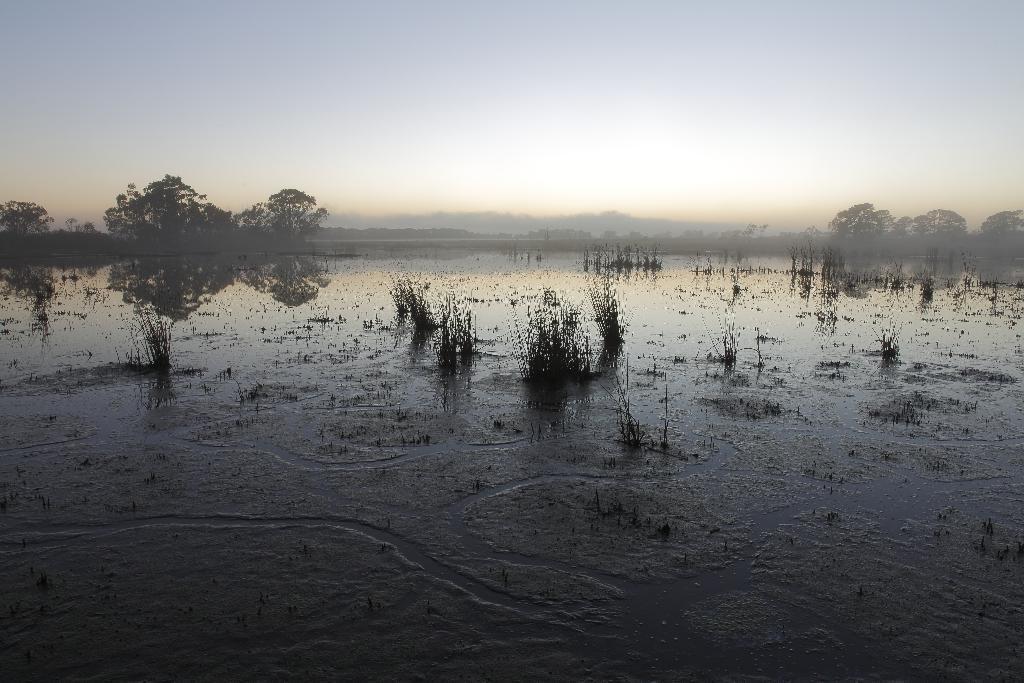Could you give a brief overview of what you see in this image? This picture is clicked outside the city. In the center we can see the green grass and a water body. In the background there is a sky and the trees and some other objects. 